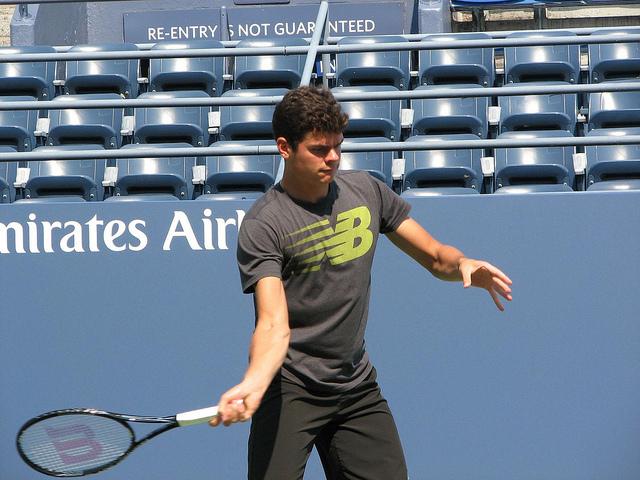What brand is the young man's shirt?
Answer briefly. New balance. What game is he playing?
Quick response, please. Tennis. Is there an airline ad in this picture?
Answer briefly. Yes. 